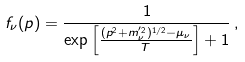<formula> <loc_0><loc_0><loc_500><loc_500>f _ { \nu } ( p ) = \frac { 1 } { \exp \left [ { \frac { ( p ^ { 2 } + m _ { \nu } ^ { ^ { \prime } 2 } ) ^ { 1 / 2 } - \mu _ { \nu } } { T } } \right ] + 1 } \, ,</formula> 